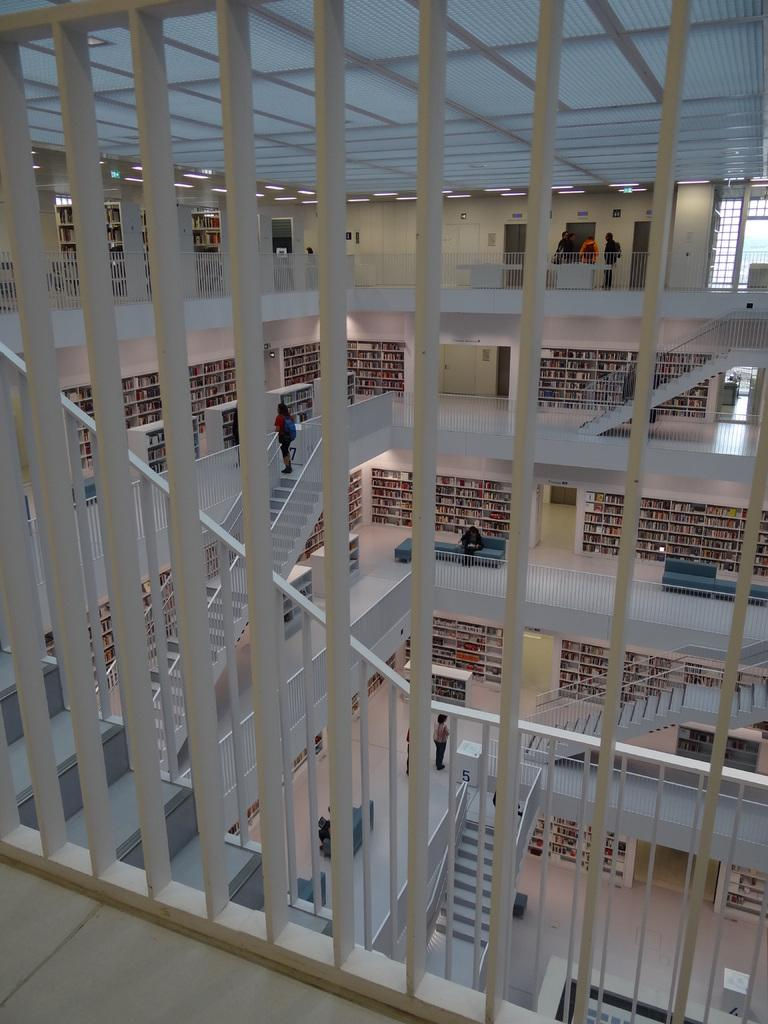What type of location is depicted in the image? The image shows an inside view of a building. What can be seen in the image that is used for cooking? There are grills in the image. What architectural feature is present in the middle of the image? There are stairs in the middle of the image. What type of steel is used to construct the spade in the image? There is no spade present in the image, so it is not possible to determine the type of steel used. 